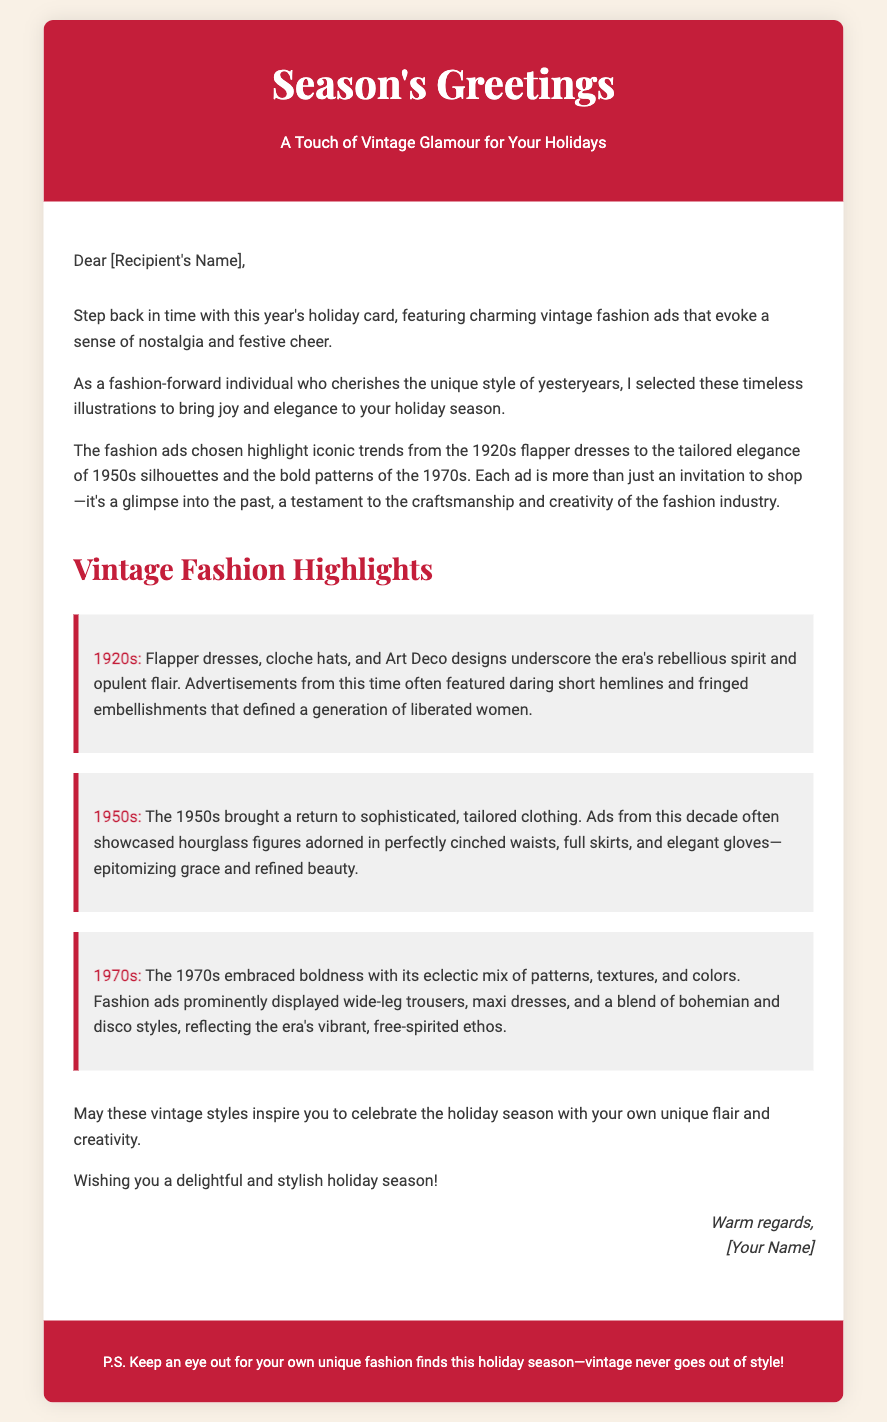what is the main theme of the card? The main theme of the card is a combination of vintage fashion and holiday greetings.
Answer: Vintage fashion who is the card addressed to? The card is addressed to the recipient, whose name is placeholder text in the document.
Answer: [Recipient's Name] which decade features flapper dresses in the highlights? The 1920s era is specifically mentioned for its flapper dresses and other styles.
Answer: 1920s what type of clothing is highlighted as popular in the 1950s? The clothing highlighted from the 1950s includes tailored outfits and hourglass figures.
Answer: Tailored clothing what is the signature sign-off in the closing? The closing signature includes a warm regards sign-off along with the sender's name placeholder.
Answer: [Your Name] how does the card suggest celebrating the holiday season? The card suggests celebrating the holiday season with unique flair and creativity inspired by vintage styles.
Answer: Unique flair and creativity how many vintage eras are mentioned in the highlights section? There are three vintage eras mentioned in the highlights section: 1920s, 1950s, and 1970s.
Answer: Three what is the color of the card's header background? The background color of the card's header is a shade of red.
Answer: #c41e3a what kind of fashion styles does the 1970s highlight feature? The 1970s highlight features bold and eclectic styles, including wide-leg trousers and maxi dresses.
Answer: Bold styles 